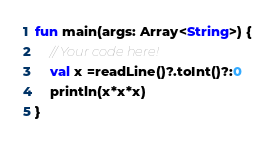<code> <loc_0><loc_0><loc_500><loc_500><_Kotlin_>fun main(args: Array<String>) {
    // Your code here!
    val x =readLine()?.toInt()?:0
    println(x*x*x)
}

</code> 